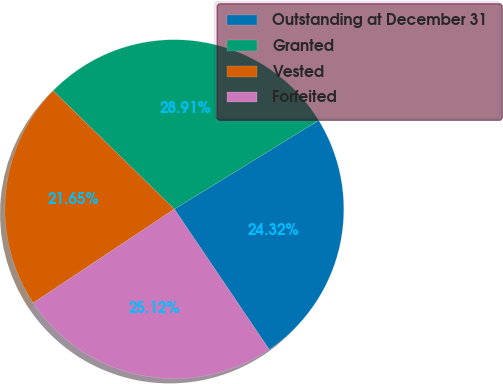<chart> <loc_0><loc_0><loc_500><loc_500><pie_chart><fcel>Outstanding at December 31<fcel>Granted<fcel>Vested<fcel>Forfeited<nl><fcel>24.32%<fcel>28.91%<fcel>21.65%<fcel>25.12%<nl></chart> 